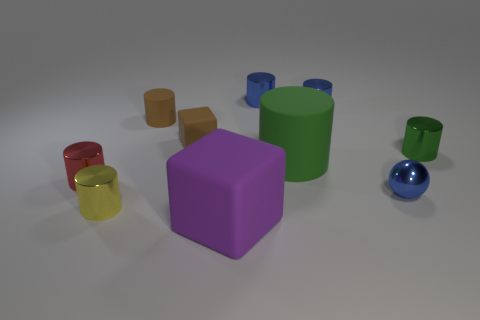What size is the blue shiny thing in front of the large rubber thing behind the big purple object?
Make the answer very short. Small. What is the color of the big matte thing that is the same shape as the tiny yellow metallic thing?
Make the answer very short. Green. What size is the red metal cylinder?
Offer a very short reply. Small. What number of spheres are either small matte things or small blue objects?
Provide a short and direct response. 1. There is another rubber thing that is the same shape as the purple thing; what is its size?
Keep it short and to the point. Small. How many large green matte things are there?
Make the answer very short. 1. Is the shape of the tiny red object the same as the matte object behind the brown matte block?
Your answer should be compact. Yes. How big is the matte object behind the brown rubber block?
Your response must be concise. Small. What is the material of the small brown cylinder?
Your answer should be compact. Rubber. Is the shape of the large object left of the large green cylinder the same as  the tiny green object?
Offer a very short reply. No. 